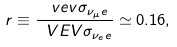Convert formula to latex. <formula><loc_0><loc_0><loc_500><loc_500>r \equiv \frac { \ v e v { \sigma _ { \nu _ { \mu } e } } } { \ V E V { \sigma _ { \nu _ { e } e } } } \simeq 0 . 1 6 ,</formula> 